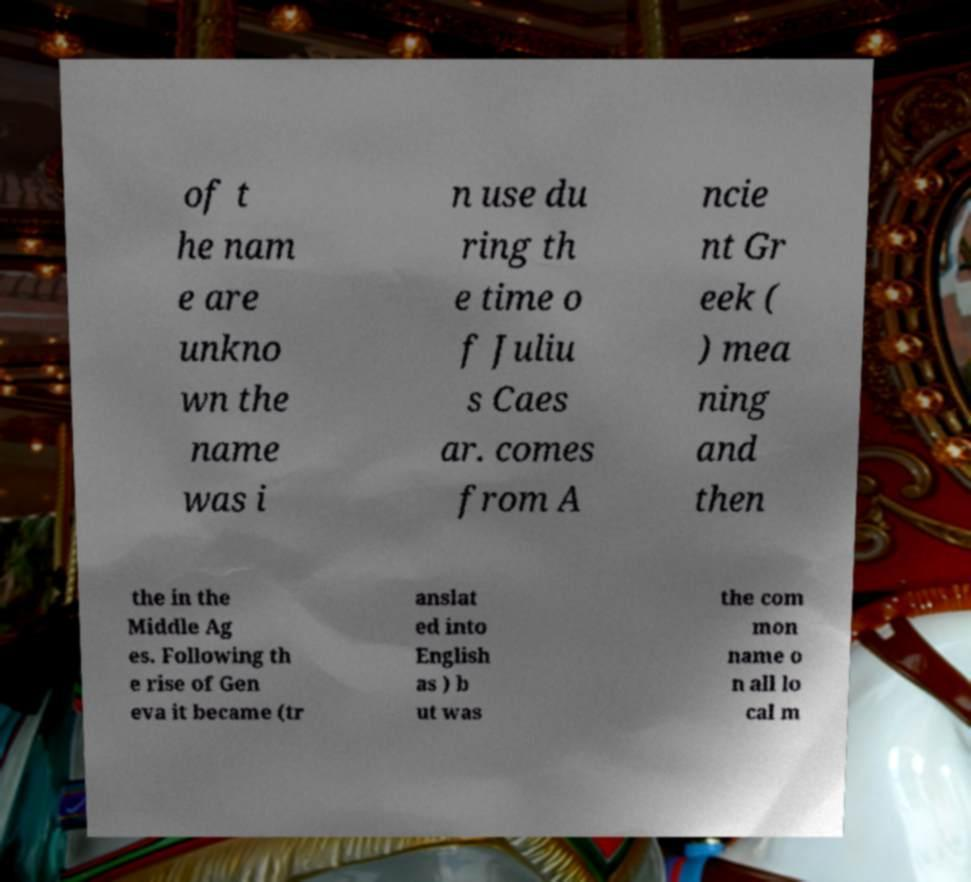For documentation purposes, I need the text within this image transcribed. Could you provide that? of t he nam e are unkno wn the name was i n use du ring th e time o f Juliu s Caes ar. comes from A ncie nt Gr eek ( ) mea ning and then the in the Middle Ag es. Following th e rise of Gen eva it became (tr anslat ed into English as ) b ut was the com mon name o n all lo cal m 